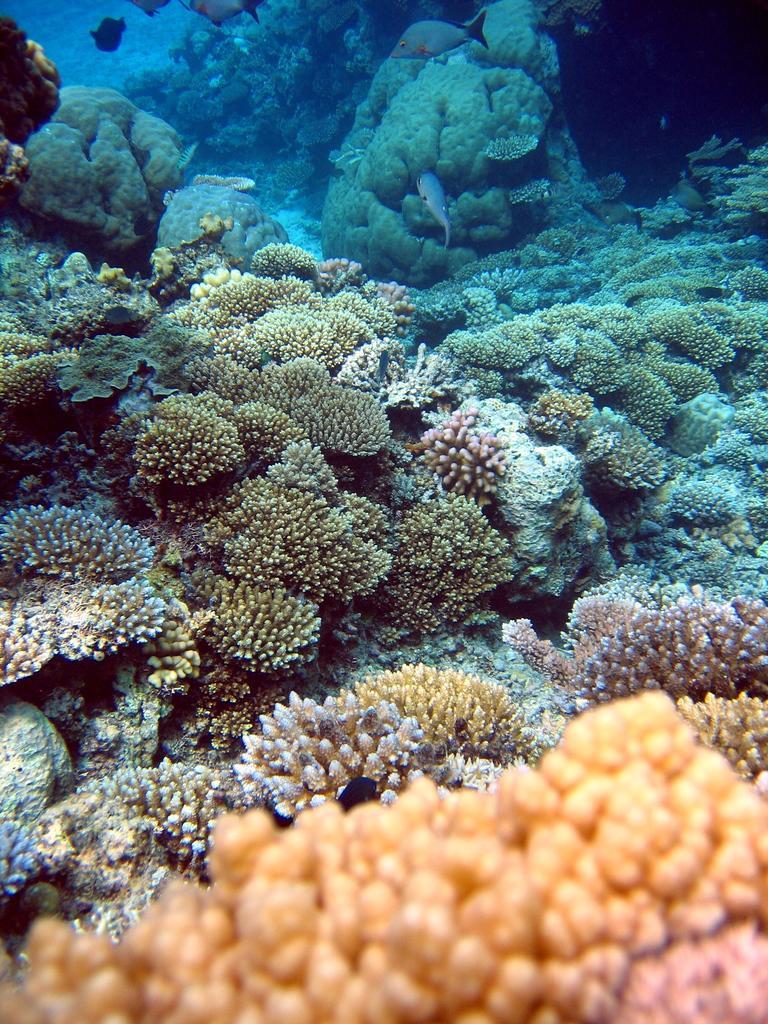Please provide a concise description of this image. In the image under the water there are corals and few fishes. 